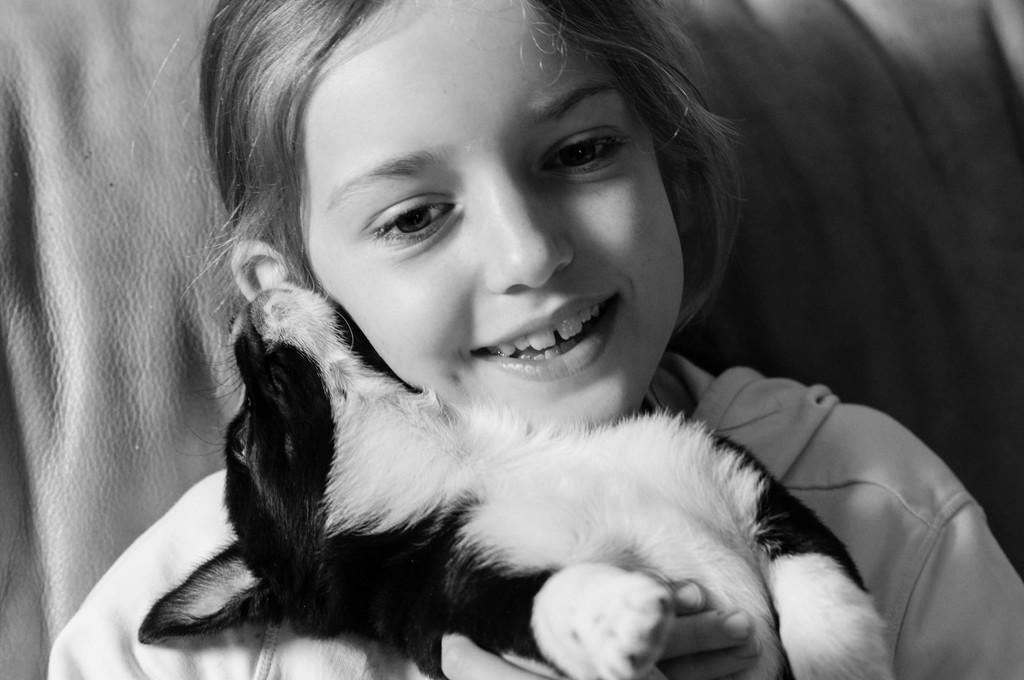Who is the main subject in the image? There is a girl in the image. What is the girl holding in the image? The girl is holding a dog. What color scheme is used in the image? The image is in black and white color. What type of balloon can be seen floating in the background of the image? There is no balloon present in the image; it is in black and white color. 